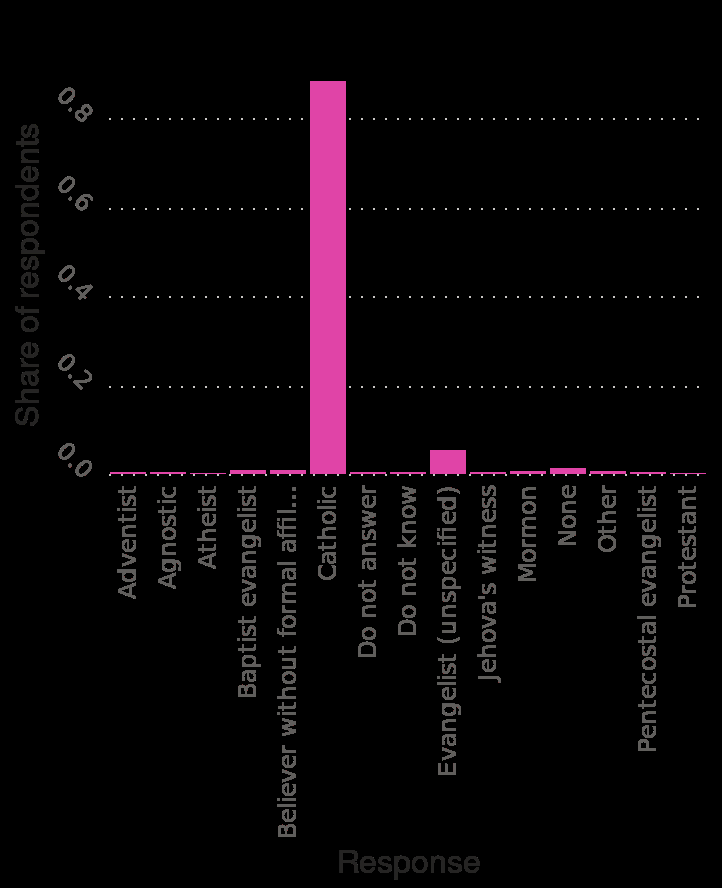<image>
What is the religious affiliation of the majority of people in the region?  Catholicism. What does the bar plot depict? The bar plot depicts the distribution of religion affiliation in Paraguay as of 2018, with each bar representing the percentage of respondents for a specific religion type. Does the bar plot depict the distribution of religion affiliation in Paraguay as of 2018 with each bar representing the number of respondents for a specific religion type, regardless of the percentage? No.The bar plot depicts the distribution of religion affiliation in Paraguay as of 2018, with each bar representing the percentage of respondents for a specific religion type. 